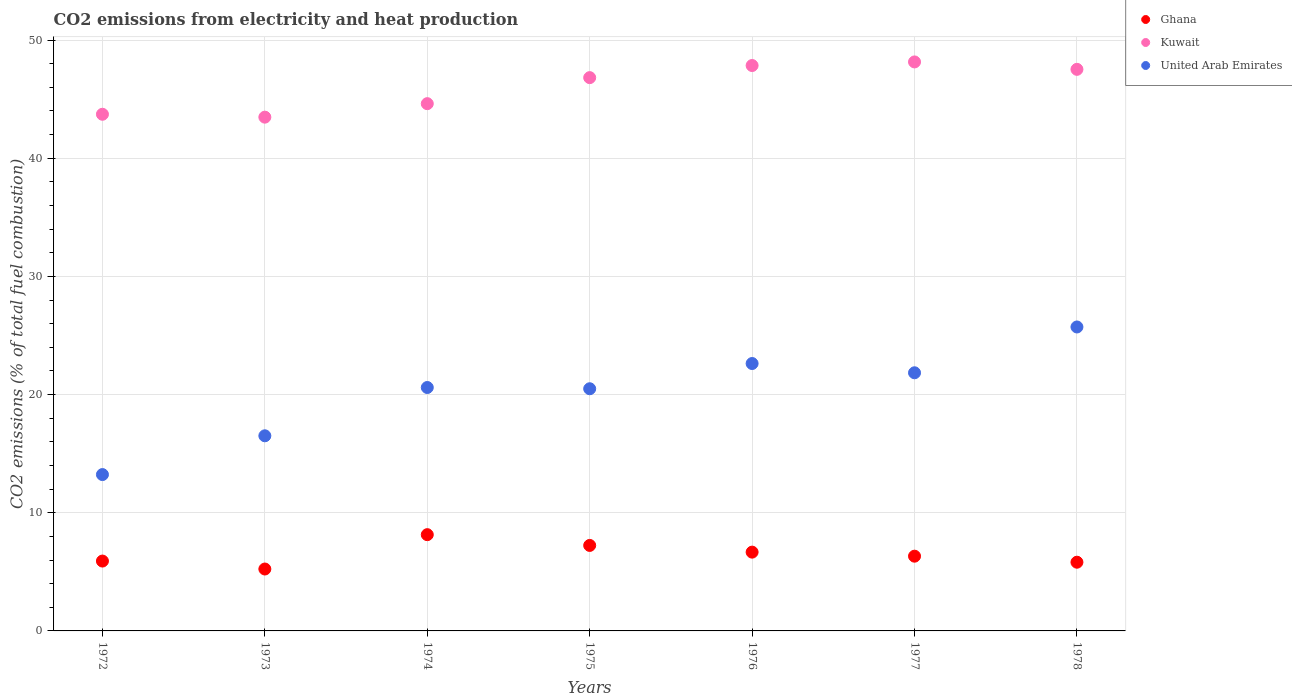How many different coloured dotlines are there?
Make the answer very short. 3. What is the amount of CO2 emitted in Ghana in 1975?
Your answer should be compact. 7.23. Across all years, what is the maximum amount of CO2 emitted in United Arab Emirates?
Provide a short and direct response. 25.72. Across all years, what is the minimum amount of CO2 emitted in Kuwait?
Your response must be concise. 43.47. In which year was the amount of CO2 emitted in Kuwait maximum?
Your answer should be very brief. 1977. In which year was the amount of CO2 emitted in United Arab Emirates minimum?
Ensure brevity in your answer.  1972. What is the total amount of CO2 emitted in United Arab Emirates in the graph?
Your response must be concise. 141.02. What is the difference between the amount of CO2 emitted in Ghana in 1977 and that in 1978?
Your answer should be very brief. 0.51. What is the difference between the amount of CO2 emitted in United Arab Emirates in 1972 and the amount of CO2 emitted in Kuwait in 1978?
Your answer should be compact. -34.29. What is the average amount of CO2 emitted in United Arab Emirates per year?
Provide a short and direct response. 20.15. In the year 1978, what is the difference between the amount of CO2 emitted in United Arab Emirates and amount of CO2 emitted in Kuwait?
Ensure brevity in your answer.  -21.8. What is the ratio of the amount of CO2 emitted in Ghana in 1977 to that in 1978?
Offer a very short reply. 1.09. Is the amount of CO2 emitted in Kuwait in 1974 less than that in 1975?
Your answer should be compact. Yes. What is the difference between the highest and the second highest amount of CO2 emitted in United Arab Emirates?
Give a very brief answer. 3.09. What is the difference between the highest and the lowest amount of CO2 emitted in United Arab Emirates?
Your answer should be very brief. 12.49. Does the amount of CO2 emitted in Ghana monotonically increase over the years?
Give a very brief answer. No. How many years are there in the graph?
Make the answer very short. 7. What is the difference between two consecutive major ticks on the Y-axis?
Provide a succinct answer. 10. Does the graph contain any zero values?
Your answer should be very brief. No. How many legend labels are there?
Offer a very short reply. 3. What is the title of the graph?
Provide a succinct answer. CO2 emissions from electricity and heat production. What is the label or title of the Y-axis?
Offer a very short reply. CO2 emissions (% of total fuel combustion). What is the CO2 emissions (% of total fuel combustion) of Ghana in 1972?
Your answer should be compact. 5.91. What is the CO2 emissions (% of total fuel combustion) of Kuwait in 1972?
Offer a terse response. 43.72. What is the CO2 emissions (% of total fuel combustion) of United Arab Emirates in 1972?
Keep it short and to the point. 13.23. What is the CO2 emissions (% of total fuel combustion) in Ghana in 1973?
Offer a very short reply. 5.24. What is the CO2 emissions (% of total fuel combustion) in Kuwait in 1973?
Provide a succinct answer. 43.47. What is the CO2 emissions (% of total fuel combustion) of United Arab Emirates in 1973?
Your answer should be compact. 16.51. What is the CO2 emissions (% of total fuel combustion) of Ghana in 1974?
Give a very brief answer. 8.14. What is the CO2 emissions (% of total fuel combustion) in Kuwait in 1974?
Your response must be concise. 44.61. What is the CO2 emissions (% of total fuel combustion) in United Arab Emirates in 1974?
Your response must be concise. 20.6. What is the CO2 emissions (% of total fuel combustion) of Ghana in 1975?
Make the answer very short. 7.23. What is the CO2 emissions (% of total fuel combustion) in Kuwait in 1975?
Keep it short and to the point. 46.82. What is the CO2 emissions (% of total fuel combustion) in United Arab Emirates in 1975?
Provide a short and direct response. 20.49. What is the CO2 emissions (% of total fuel combustion) of Ghana in 1976?
Your answer should be very brief. 6.67. What is the CO2 emissions (% of total fuel combustion) of Kuwait in 1976?
Your answer should be compact. 47.84. What is the CO2 emissions (% of total fuel combustion) of United Arab Emirates in 1976?
Give a very brief answer. 22.63. What is the CO2 emissions (% of total fuel combustion) of Ghana in 1977?
Give a very brief answer. 6.32. What is the CO2 emissions (% of total fuel combustion) in Kuwait in 1977?
Ensure brevity in your answer.  48.15. What is the CO2 emissions (% of total fuel combustion) in United Arab Emirates in 1977?
Provide a succinct answer. 21.84. What is the CO2 emissions (% of total fuel combustion) of Ghana in 1978?
Keep it short and to the point. 5.81. What is the CO2 emissions (% of total fuel combustion) in Kuwait in 1978?
Offer a terse response. 47.52. What is the CO2 emissions (% of total fuel combustion) of United Arab Emirates in 1978?
Ensure brevity in your answer.  25.72. Across all years, what is the maximum CO2 emissions (% of total fuel combustion) of Ghana?
Your answer should be very brief. 8.14. Across all years, what is the maximum CO2 emissions (% of total fuel combustion) in Kuwait?
Provide a succinct answer. 48.15. Across all years, what is the maximum CO2 emissions (% of total fuel combustion) in United Arab Emirates?
Provide a short and direct response. 25.72. Across all years, what is the minimum CO2 emissions (% of total fuel combustion) in Ghana?
Offer a terse response. 5.24. Across all years, what is the minimum CO2 emissions (% of total fuel combustion) in Kuwait?
Your answer should be very brief. 43.47. Across all years, what is the minimum CO2 emissions (% of total fuel combustion) in United Arab Emirates?
Provide a succinct answer. 13.23. What is the total CO2 emissions (% of total fuel combustion) of Ghana in the graph?
Ensure brevity in your answer.  45.33. What is the total CO2 emissions (% of total fuel combustion) in Kuwait in the graph?
Give a very brief answer. 322.13. What is the total CO2 emissions (% of total fuel combustion) of United Arab Emirates in the graph?
Your answer should be compact. 141.02. What is the difference between the CO2 emissions (% of total fuel combustion) of Ghana in 1972 and that in 1973?
Offer a very short reply. 0.67. What is the difference between the CO2 emissions (% of total fuel combustion) of Kuwait in 1972 and that in 1973?
Your response must be concise. 0.24. What is the difference between the CO2 emissions (% of total fuel combustion) of United Arab Emirates in 1972 and that in 1973?
Make the answer very short. -3.28. What is the difference between the CO2 emissions (% of total fuel combustion) of Ghana in 1972 and that in 1974?
Keep it short and to the point. -2.23. What is the difference between the CO2 emissions (% of total fuel combustion) of Kuwait in 1972 and that in 1974?
Offer a very short reply. -0.9. What is the difference between the CO2 emissions (% of total fuel combustion) in United Arab Emirates in 1972 and that in 1974?
Make the answer very short. -7.37. What is the difference between the CO2 emissions (% of total fuel combustion) in Ghana in 1972 and that in 1975?
Ensure brevity in your answer.  -1.32. What is the difference between the CO2 emissions (% of total fuel combustion) in Kuwait in 1972 and that in 1975?
Give a very brief answer. -3.1. What is the difference between the CO2 emissions (% of total fuel combustion) in United Arab Emirates in 1972 and that in 1975?
Your answer should be compact. -7.26. What is the difference between the CO2 emissions (% of total fuel combustion) of Ghana in 1972 and that in 1976?
Make the answer very short. -0.76. What is the difference between the CO2 emissions (% of total fuel combustion) in Kuwait in 1972 and that in 1976?
Offer a terse response. -4.12. What is the difference between the CO2 emissions (% of total fuel combustion) in United Arab Emirates in 1972 and that in 1976?
Make the answer very short. -9.4. What is the difference between the CO2 emissions (% of total fuel combustion) of Ghana in 1972 and that in 1977?
Your answer should be very brief. -0.41. What is the difference between the CO2 emissions (% of total fuel combustion) in Kuwait in 1972 and that in 1977?
Keep it short and to the point. -4.43. What is the difference between the CO2 emissions (% of total fuel combustion) in United Arab Emirates in 1972 and that in 1977?
Offer a terse response. -8.61. What is the difference between the CO2 emissions (% of total fuel combustion) in Ghana in 1972 and that in 1978?
Give a very brief answer. 0.1. What is the difference between the CO2 emissions (% of total fuel combustion) in Kuwait in 1972 and that in 1978?
Keep it short and to the point. -3.8. What is the difference between the CO2 emissions (% of total fuel combustion) in United Arab Emirates in 1972 and that in 1978?
Make the answer very short. -12.49. What is the difference between the CO2 emissions (% of total fuel combustion) in Ghana in 1973 and that in 1974?
Give a very brief answer. -2.91. What is the difference between the CO2 emissions (% of total fuel combustion) in Kuwait in 1973 and that in 1974?
Provide a succinct answer. -1.14. What is the difference between the CO2 emissions (% of total fuel combustion) of United Arab Emirates in 1973 and that in 1974?
Ensure brevity in your answer.  -4.09. What is the difference between the CO2 emissions (% of total fuel combustion) of Ghana in 1973 and that in 1975?
Offer a very short reply. -2. What is the difference between the CO2 emissions (% of total fuel combustion) in Kuwait in 1973 and that in 1975?
Offer a terse response. -3.34. What is the difference between the CO2 emissions (% of total fuel combustion) of United Arab Emirates in 1973 and that in 1975?
Make the answer very short. -3.98. What is the difference between the CO2 emissions (% of total fuel combustion) of Ghana in 1973 and that in 1976?
Your response must be concise. -1.43. What is the difference between the CO2 emissions (% of total fuel combustion) in Kuwait in 1973 and that in 1976?
Provide a short and direct response. -4.37. What is the difference between the CO2 emissions (% of total fuel combustion) in United Arab Emirates in 1973 and that in 1976?
Provide a succinct answer. -6.12. What is the difference between the CO2 emissions (% of total fuel combustion) of Ghana in 1973 and that in 1977?
Make the answer very short. -1.09. What is the difference between the CO2 emissions (% of total fuel combustion) in Kuwait in 1973 and that in 1977?
Your answer should be very brief. -4.67. What is the difference between the CO2 emissions (% of total fuel combustion) in United Arab Emirates in 1973 and that in 1977?
Provide a succinct answer. -5.33. What is the difference between the CO2 emissions (% of total fuel combustion) in Ghana in 1973 and that in 1978?
Provide a short and direct response. -0.58. What is the difference between the CO2 emissions (% of total fuel combustion) of Kuwait in 1973 and that in 1978?
Your answer should be very brief. -4.05. What is the difference between the CO2 emissions (% of total fuel combustion) of United Arab Emirates in 1973 and that in 1978?
Provide a succinct answer. -9.21. What is the difference between the CO2 emissions (% of total fuel combustion) in Ghana in 1974 and that in 1975?
Offer a very short reply. 0.91. What is the difference between the CO2 emissions (% of total fuel combustion) in Kuwait in 1974 and that in 1975?
Give a very brief answer. -2.2. What is the difference between the CO2 emissions (% of total fuel combustion) in United Arab Emirates in 1974 and that in 1975?
Your response must be concise. 0.11. What is the difference between the CO2 emissions (% of total fuel combustion) in Ghana in 1974 and that in 1976?
Keep it short and to the point. 1.48. What is the difference between the CO2 emissions (% of total fuel combustion) of Kuwait in 1974 and that in 1976?
Keep it short and to the point. -3.23. What is the difference between the CO2 emissions (% of total fuel combustion) in United Arab Emirates in 1974 and that in 1976?
Give a very brief answer. -2.03. What is the difference between the CO2 emissions (% of total fuel combustion) in Ghana in 1974 and that in 1977?
Provide a succinct answer. 1.82. What is the difference between the CO2 emissions (% of total fuel combustion) of Kuwait in 1974 and that in 1977?
Keep it short and to the point. -3.53. What is the difference between the CO2 emissions (% of total fuel combustion) of United Arab Emirates in 1974 and that in 1977?
Give a very brief answer. -1.25. What is the difference between the CO2 emissions (% of total fuel combustion) in Ghana in 1974 and that in 1978?
Your answer should be very brief. 2.33. What is the difference between the CO2 emissions (% of total fuel combustion) of Kuwait in 1974 and that in 1978?
Your response must be concise. -2.9. What is the difference between the CO2 emissions (% of total fuel combustion) in United Arab Emirates in 1974 and that in 1978?
Provide a short and direct response. -5.12. What is the difference between the CO2 emissions (% of total fuel combustion) of Ghana in 1975 and that in 1976?
Provide a short and direct response. 0.57. What is the difference between the CO2 emissions (% of total fuel combustion) of Kuwait in 1975 and that in 1976?
Provide a short and direct response. -1.02. What is the difference between the CO2 emissions (% of total fuel combustion) of United Arab Emirates in 1975 and that in 1976?
Provide a succinct answer. -2.13. What is the difference between the CO2 emissions (% of total fuel combustion) of Ghana in 1975 and that in 1977?
Give a very brief answer. 0.91. What is the difference between the CO2 emissions (% of total fuel combustion) of Kuwait in 1975 and that in 1977?
Provide a succinct answer. -1.33. What is the difference between the CO2 emissions (% of total fuel combustion) of United Arab Emirates in 1975 and that in 1977?
Your answer should be compact. -1.35. What is the difference between the CO2 emissions (% of total fuel combustion) in Ghana in 1975 and that in 1978?
Give a very brief answer. 1.42. What is the difference between the CO2 emissions (% of total fuel combustion) in Kuwait in 1975 and that in 1978?
Provide a succinct answer. -0.7. What is the difference between the CO2 emissions (% of total fuel combustion) in United Arab Emirates in 1975 and that in 1978?
Your answer should be very brief. -5.23. What is the difference between the CO2 emissions (% of total fuel combustion) of Ghana in 1976 and that in 1977?
Offer a terse response. 0.34. What is the difference between the CO2 emissions (% of total fuel combustion) in Kuwait in 1976 and that in 1977?
Make the answer very short. -0.3. What is the difference between the CO2 emissions (% of total fuel combustion) in United Arab Emirates in 1976 and that in 1977?
Ensure brevity in your answer.  0.78. What is the difference between the CO2 emissions (% of total fuel combustion) of Ghana in 1976 and that in 1978?
Give a very brief answer. 0.85. What is the difference between the CO2 emissions (% of total fuel combustion) in Kuwait in 1976 and that in 1978?
Offer a very short reply. 0.32. What is the difference between the CO2 emissions (% of total fuel combustion) of United Arab Emirates in 1976 and that in 1978?
Your answer should be very brief. -3.09. What is the difference between the CO2 emissions (% of total fuel combustion) in Ghana in 1977 and that in 1978?
Ensure brevity in your answer.  0.51. What is the difference between the CO2 emissions (% of total fuel combustion) in Kuwait in 1977 and that in 1978?
Your answer should be compact. 0.63. What is the difference between the CO2 emissions (% of total fuel combustion) in United Arab Emirates in 1977 and that in 1978?
Keep it short and to the point. -3.88. What is the difference between the CO2 emissions (% of total fuel combustion) in Ghana in 1972 and the CO2 emissions (% of total fuel combustion) in Kuwait in 1973?
Provide a succinct answer. -37.56. What is the difference between the CO2 emissions (% of total fuel combustion) of Ghana in 1972 and the CO2 emissions (% of total fuel combustion) of United Arab Emirates in 1973?
Your response must be concise. -10.6. What is the difference between the CO2 emissions (% of total fuel combustion) in Kuwait in 1972 and the CO2 emissions (% of total fuel combustion) in United Arab Emirates in 1973?
Your answer should be compact. 27.21. What is the difference between the CO2 emissions (% of total fuel combustion) in Ghana in 1972 and the CO2 emissions (% of total fuel combustion) in Kuwait in 1974?
Your answer should be compact. -38.7. What is the difference between the CO2 emissions (% of total fuel combustion) of Ghana in 1972 and the CO2 emissions (% of total fuel combustion) of United Arab Emirates in 1974?
Provide a succinct answer. -14.69. What is the difference between the CO2 emissions (% of total fuel combustion) in Kuwait in 1972 and the CO2 emissions (% of total fuel combustion) in United Arab Emirates in 1974?
Keep it short and to the point. 23.12. What is the difference between the CO2 emissions (% of total fuel combustion) in Ghana in 1972 and the CO2 emissions (% of total fuel combustion) in Kuwait in 1975?
Provide a succinct answer. -40.91. What is the difference between the CO2 emissions (% of total fuel combustion) of Ghana in 1972 and the CO2 emissions (% of total fuel combustion) of United Arab Emirates in 1975?
Your answer should be very brief. -14.58. What is the difference between the CO2 emissions (% of total fuel combustion) of Kuwait in 1972 and the CO2 emissions (% of total fuel combustion) of United Arab Emirates in 1975?
Ensure brevity in your answer.  23.23. What is the difference between the CO2 emissions (% of total fuel combustion) in Ghana in 1972 and the CO2 emissions (% of total fuel combustion) in Kuwait in 1976?
Ensure brevity in your answer.  -41.93. What is the difference between the CO2 emissions (% of total fuel combustion) of Ghana in 1972 and the CO2 emissions (% of total fuel combustion) of United Arab Emirates in 1976?
Keep it short and to the point. -16.72. What is the difference between the CO2 emissions (% of total fuel combustion) in Kuwait in 1972 and the CO2 emissions (% of total fuel combustion) in United Arab Emirates in 1976?
Offer a terse response. 21.09. What is the difference between the CO2 emissions (% of total fuel combustion) of Ghana in 1972 and the CO2 emissions (% of total fuel combustion) of Kuwait in 1977?
Your answer should be very brief. -42.23. What is the difference between the CO2 emissions (% of total fuel combustion) in Ghana in 1972 and the CO2 emissions (% of total fuel combustion) in United Arab Emirates in 1977?
Your answer should be compact. -15.93. What is the difference between the CO2 emissions (% of total fuel combustion) of Kuwait in 1972 and the CO2 emissions (% of total fuel combustion) of United Arab Emirates in 1977?
Offer a very short reply. 21.88. What is the difference between the CO2 emissions (% of total fuel combustion) of Ghana in 1972 and the CO2 emissions (% of total fuel combustion) of Kuwait in 1978?
Make the answer very short. -41.61. What is the difference between the CO2 emissions (% of total fuel combustion) in Ghana in 1972 and the CO2 emissions (% of total fuel combustion) in United Arab Emirates in 1978?
Offer a very short reply. -19.81. What is the difference between the CO2 emissions (% of total fuel combustion) in Kuwait in 1972 and the CO2 emissions (% of total fuel combustion) in United Arab Emirates in 1978?
Make the answer very short. 18. What is the difference between the CO2 emissions (% of total fuel combustion) of Ghana in 1973 and the CO2 emissions (% of total fuel combustion) of Kuwait in 1974?
Provide a short and direct response. -39.38. What is the difference between the CO2 emissions (% of total fuel combustion) of Ghana in 1973 and the CO2 emissions (% of total fuel combustion) of United Arab Emirates in 1974?
Offer a very short reply. -15.36. What is the difference between the CO2 emissions (% of total fuel combustion) in Kuwait in 1973 and the CO2 emissions (% of total fuel combustion) in United Arab Emirates in 1974?
Make the answer very short. 22.88. What is the difference between the CO2 emissions (% of total fuel combustion) of Ghana in 1973 and the CO2 emissions (% of total fuel combustion) of Kuwait in 1975?
Provide a short and direct response. -41.58. What is the difference between the CO2 emissions (% of total fuel combustion) in Ghana in 1973 and the CO2 emissions (% of total fuel combustion) in United Arab Emirates in 1975?
Keep it short and to the point. -15.25. What is the difference between the CO2 emissions (% of total fuel combustion) in Kuwait in 1973 and the CO2 emissions (% of total fuel combustion) in United Arab Emirates in 1975?
Offer a very short reply. 22.98. What is the difference between the CO2 emissions (% of total fuel combustion) in Ghana in 1973 and the CO2 emissions (% of total fuel combustion) in Kuwait in 1976?
Give a very brief answer. -42.6. What is the difference between the CO2 emissions (% of total fuel combustion) of Ghana in 1973 and the CO2 emissions (% of total fuel combustion) of United Arab Emirates in 1976?
Provide a short and direct response. -17.39. What is the difference between the CO2 emissions (% of total fuel combustion) of Kuwait in 1973 and the CO2 emissions (% of total fuel combustion) of United Arab Emirates in 1976?
Offer a very short reply. 20.85. What is the difference between the CO2 emissions (% of total fuel combustion) of Ghana in 1973 and the CO2 emissions (% of total fuel combustion) of Kuwait in 1977?
Your response must be concise. -42.91. What is the difference between the CO2 emissions (% of total fuel combustion) in Ghana in 1973 and the CO2 emissions (% of total fuel combustion) in United Arab Emirates in 1977?
Your answer should be compact. -16.6. What is the difference between the CO2 emissions (% of total fuel combustion) in Kuwait in 1973 and the CO2 emissions (% of total fuel combustion) in United Arab Emirates in 1977?
Make the answer very short. 21.63. What is the difference between the CO2 emissions (% of total fuel combustion) of Ghana in 1973 and the CO2 emissions (% of total fuel combustion) of Kuwait in 1978?
Offer a terse response. -42.28. What is the difference between the CO2 emissions (% of total fuel combustion) of Ghana in 1973 and the CO2 emissions (% of total fuel combustion) of United Arab Emirates in 1978?
Offer a very short reply. -20.48. What is the difference between the CO2 emissions (% of total fuel combustion) in Kuwait in 1973 and the CO2 emissions (% of total fuel combustion) in United Arab Emirates in 1978?
Provide a short and direct response. 17.75. What is the difference between the CO2 emissions (% of total fuel combustion) of Ghana in 1974 and the CO2 emissions (% of total fuel combustion) of Kuwait in 1975?
Keep it short and to the point. -38.67. What is the difference between the CO2 emissions (% of total fuel combustion) of Ghana in 1974 and the CO2 emissions (% of total fuel combustion) of United Arab Emirates in 1975?
Offer a terse response. -12.35. What is the difference between the CO2 emissions (% of total fuel combustion) of Kuwait in 1974 and the CO2 emissions (% of total fuel combustion) of United Arab Emirates in 1975?
Make the answer very short. 24.12. What is the difference between the CO2 emissions (% of total fuel combustion) in Ghana in 1974 and the CO2 emissions (% of total fuel combustion) in Kuwait in 1976?
Ensure brevity in your answer.  -39.7. What is the difference between the CO2 emissions (% of total fuel combustion) in Ghana in 1974 and the CO2 emissions (% of total fuel combustion) in United Arab Emirates in 1976?
Offer a terse response. -14.48. What is the difference between the CO2 emissions (% of total fuel combustion) in Kuwait in 1974 and the CO2 emissions (% of total fuel combustion) in United Arab Emirates in 1976?
Make the answer very short. 21.99. What is the difference between the CO2 emissions (% of total fuel combustion) in Ghana in 1974 and the CO2 emissions (% of total fuel combustion) in Kuwait in 1977?
Offer a terse response. -40. What is the difference between the CO2 emissions (% of total fuel combustion) in Ghana in 1974 and the CO2 emissions (% of total fuel combustion) in United Arab Emirates in 1977?
Ensure brevity in your answer.  -13.7. What is the difference between the CO2 emissions (% of total fuel combustion) in Kuwait in 1974 and the CO2 emissions (% of total fuel combustion) in United Arab Emirates in 1977?
Provide a short and direct response. 22.77. What is the difference between the CO2 emissions (% of total fuel combustion) of Ghana in 1974 and the CO2 emissions (% of total fuel combustion) of Kuwait in 1978?
Keep it short and to the point. -39.37. What is the difference between the CO2 emissions (% of total fuel combustion) of Ghana in 1974 and the CO2 emissions (% of total fuel combustion) of United Arab Emirates in 1978?
Make the answer very short. -17.57. What is the difference between the CO2 emissions (% of total fuel combustion) of Kuwait in 1974 and the CO2 emissions (% of total fuel combustion) of United Arab Emirates in 1978?
Provide a succinct answer. 18.9. What is the difference between the CO2 emissions (% of total fuel combustion) in Ghana in 1975 and the CO2 emissions (% of total fuel combustion) in Kuwait in 1976?
Your response must be concise. -40.61. What is the difference between the CO2 emissions (% of total fuel combustion) in Ghana in 1975 and the CO2 emissions (% of total fuel combustion) in United Arab Emirates in 1976?
Your response must be concise. -15.39. What is the difference between the CO2 emissions (% of total fuel combustion) in Kuwait in 1975 and the CO2 emissions (% of total fuel combustion) in United Arab Emirates in 1976?
Your answer should be very brief. 24.19. What is the difference between the CO2 emissions (% of total fuel combustion) of Ghana in 1975 and the CO2 emissions (% of total fuel combustion) of Kuwait in 1977?
Your response must be concise. -40.91. What is the difference between the CO2 emissions (% of total fuel combustion) of Ghana in 1975 and the CO2 emissions (% of total fuel combustion) of United Arab Emirates in 1977?
Provide a short and direct response. -14.61. What is the difference between the CO2 emissions (% of total fuel combustion) in Kuwait in 1975 and the CO2 emissions (% of total fuel combustion) in United Arab Emirates in 1977?
Offer a terse response. 24.97. What is the difference between the CO2 emissions (% of total fuel combustion) of Ghana in 1975 and the CO2 emissions (% of total fuel combustion) of Kuwait in 1978?
Offer a very short reply. -40.28. What is the difference between the CO2 emissions (% of total fuel combustion) of Ghana in 1975 and the CO2 emissions (% of total fuel combustion) of United Arab Emirates in 1978?
Make the answer very short. -18.48. What is the difference between the CO2 emissions (% of total fuel combustion) of Kuwait in 1975 and the CO2 emissions (% of total fuel combustion) of United Arab Emirates in 1978?
Give a very brief answer. 21.1. What is the difference between the CO2 emissions (% of total fuel combustion) of Ghana in 1976 and the CO2 emissions (% of total fuel combustion) of Kuwait in 1977?
Make the answer very short. -41.48. What is the difference between the CO2 emissions (% of total fuel combustion) in Ghana in 1976 and the CO2 emissions (% of total fuel combustion) in United Arab Emirates in 1977?
Provide a short and direct response. -15.18. What is the difference between the CO2 emissions (% of total fuel combustion) of Kuwait in 1976 and the CO2 emissions (% of total fuel combustion) of United Arab Emirates in 1977?
Offer a very short reply. 26. What is the difference between the CO2 emissions (% of total fuel combustion) in Ghana in 1976 and the CO2 emissions (% of total fuel combustion) in Kuwait in 1978?
Your response must be concise. -40.85. What is the difference between the CO2 emissions (% of total fuel combustion) in Ghana in 1976 and the CO2 emissions (% of total fuel combustion) in United Arab Emirates in 1978?
Your response must be concise. -19.05. What is the difference between the CO2 emissions (% of total fuel combustion) of Kuwait in 1976 and the CO2 emissions (% of total fuel combustion) of United Arab Emirates in 1978?
Your response must be concise. 22.12. What is the difference between the CO2 emissions (% of total fuel combustion) in Ghana in 1977 and the CO2 emissions (% of total fuel combustion) in Kuwait in 1978?
Provide a succinct answer. -41.19. What is the difference between the CO2 emissions (% of total fuel combustion) of Ghana in 1977 and the CO2 emissions (% of total fuel combustion) of United Arab Emirates in 1978?
Offer a terse response. -19.39. What is the difference between the CO2 emissions (% of total fuel combustion) in Kuwait in 1977 and the CO2 emissions (% of total fuel combustion) in United Arab Emirates in 1978?
Your answer should be compact. 22.43. What is the average CO2 emissions (% of total fuel combustion) of Ghana per year?
Your response must be concise. 6.48. What is the average CO2 emissions (% of total fuel combustion) in Kuwait per year?
Your response must be concise. 46.02. What is the average CO2 emissions (% of total fuel combustion) of United Arab Emirates per year?
Provide a succinct answer. 20.15. In the year 1972, what is the difference between the CO2 emissions (% of total fuel combustion) of Ghana and CO2 emissions (% of total fuel combustion) of Kuwait?
Offer a terse response. -37.81. In the year 1972, what is the difference between the CO2 emissions (% of total fuel combustion) in Ghana and CO2 emissions (% of total fuel combustion) in United Arab Emirates?
Provide a succinct answer. -7.32. In the year 1972, what is the difference between the CO2 emissions (% of total fuel combustion) of Kuwait and CO2 emissions (% of total fuel combustion) of United Arab Emirates?
Your answer should be very brief. 30.49. In the year 1973, what is the difference between the CO2 emissions (% of total fuel combustion) in Ghana and CO2 emissions (% of total fuel combustion) in Kuwait?
Keep it short and to the point. -38.23. In the year 1973, what is the difference between the CO2 emissions (% of total fuel combustion) in Ghana and CO2 emissions (% of total fuel combustion) in United Arab Emirates?
Your answer should be very brief. -11.27. In the year 1973, what is the difference between the CO2 emissions (% of total fuel combustion) in Kuwait and CO2 emissions (% of total fuel combustion) in United Arab Emirates?
Your response must be concise. 26.96. In the year 1974, what is the difference between the CO2 emissions (% of total fuel combustion) of Ghana and CO2 emissions (% of total fuel combustion) of Kuwait?
Keep it short and to the point. -36.47. In the year 1974, what is the difference between the CO2 emissions (% of total fuel combustion) of Ghana and CO2 emissions (% of total fuel combustion) of United Arab Emirates?
Ensure brevity in your answer.  -12.45. In the year 1974, what is the difference between the CO2 emissions (% of total fuel combustion) in Kuwait and CO2 emissions (% of total fuel combustion) in United Arab Emirates?
Your response must be concise. 24.02. In the year 1975, what is the difference between the CO2 emissions (% of total fuel combustion) of Ghana and CO2 emissions (% of total fuel combustion) of Kuwait?
Make the answer very short. -39.58. In the year 1975, what is the difference between the CO2 emissions (% of total fuel combustion) in Ghana and CO2 emissions (% of total fuel combustion) in United Arab Emirates?
Your response must be concise. -13.26. In the year 1975, what is the difference between the CO2 emissions (% of total fuel combustion) of Kuwait and CO2 emissions (% of total fuel combustion) of United Arab Emirates?
Keep it short and to the point. 26.33. In the year 1976, what is the difference between the CO2 emissions (% of total fuel combustion) in Ghana and CO2 emissions (% of total fuel combustion) in Kuwait?
Keep it short and to the point. -41.18. In the year 1976, what is the difference between the CO2 emissions (% of total fuel combustion) in Ghana and CO2 emissions (% of total fuel combustion) in United Arab Emirates?
Give a very brief answer. -15.96. In the year 1976, what is the difference between the CO2 emissions (% of total fuel combustion) in Kuwait and CO2 emissions (% of total fuel combustion) in United Arab Emirates?
Make the answer very short. 25.22. In the year 1977, what is the difference between the CO2 emissions (% of total fuel combustion) of Ghana and CO2 emissions (% of total fuel combustion) of Kuwait?
Give a very brief answer. -41.82. In the year 1977, what is the difference between the CO2 emissions (% of total fuel combustion) of Ghana and CO2 emissions (% of total fuel combustion) of United Arab Emirates?
Ensure brevity in your answer.  -15.52. In the year 1977, what is the difference between the CO2 emissions (% of total fuel combustion) of Kuwait and CO2 emissions (% of total fuel combustion) of United Arab Emirates?
Your answer should be compact. 26.3. In the year 1978, what is the difference between the CO2 emissions (% of total fuel combustion) of Ghana and CO2 emissions (% of total fuel combustion) of Kuwait?
Provide a short and direct response. -41.7. In the year 1978, what is the difference between the CO2 emissions (% of total fuel combustion) of Ghana and CO2 emissions (% of total fuel combustion) of United Arab Emirates?
Offer a very short reply. -19.91. In the year 1978, what is the difference between the CO2 emissions (% of total fuel combustion) of Kuwait and CO2 emissions (% of total fuel combustion) of United Arab Emirates?
Provide a succinct answer. 21.8. What is the ratio of the CO2 emissions (% of total fuel combustion) of Ghana in 1972 to that in 1973?
Provide a succinct answer. 1.13. What is the ratio of the CO2 emissions (% of total fuel combustion) of Kuwait in 1972 to that in 1973?
Your response must be concise. 1.01. What is the ratio of the CO2 emissions (% of total fuel combustion) in United Arab Emirates in 1972 to that in 1973?
Ensure brevity in your answer.  0.8. What is the ratio of the CO2 emissions (% of total fuel combustion) of Ghana in 1972 to that in 1974?
Provide a short and direct response. 0.73. What is the ratio of the CO2 emissions (% of total fuel combustion) in Kuwait in 1972 to that in 1974?
Offer a very short reply. 0.98. What is the ratio of the CO2 emissions (% of total fuel combustion) in United Arab Emirates in 1972 to that in 1974?
Your answer should be very brief. 0.64. What is the ratio of the CO2 emissions (% of total fuel combustion) of Ghana in 1972 to that in 1975?
Your answer should be very brief. 0.82. What is the ratio of the CO2 emissions (% of total fuel combustion) in Kuwait in 1972 to that in 1975?
Your response must be concise. 0.93. What is the ratio of the CO2 emissions (% of total fuel combustion) in United Arab Emirates in 1972 to that in 1975?
Your answer should be compact. 0.65. What is the ratio of the CO2 emissions (% of total fuel combustion) in Ghana in 1972 to that in 1976?
Your answer should be very brief. 0.89. What is the ratio of the CO2 emissions (% of total fuel combustion) of Kuwait in 1972 to that in 1976?
Offer a very short reply. 0.91. What is the ratio of the CO2 emissions (% of total fuel combustion) in United Arab Emirates in 1972 to that in 1976?
Ensure brevity in your answer.  0.58. What is the ratio of the CO2 emissions (% of total fuel combustion) in Ghana in 1972 to that in 1977?
Your answer should be compact. 0.93. What is the ratio of the CO2 emissions (% of total fuel combustion) in Kuwait in 1972 to that in 1977?
Offer a terse response. 0.91. What is the ratio of the CO2 emissions (% of total fuel combustion) of United Arab Emirates in 1972 to that in 1977?
Offer a terse response. 0.61. What is the ratio of the CO2 emissions (% of total fuel combustion) in Ghana in 1972 to that in 1978?
Provide a short and direct response. 1.02. What is the ratio of the CO2 emissions (% of total fuel combustion) in United Arab Emirates in 1972 to that in 1978?
Keep it short and to the point. 0.51. What is the ratio of the CO2 emissions (% of total fuel combustion) of Ghana in 1973 to that in 1974?
Provide a succinct answer. 0.64. What is the ratio of the CO2 emissions (% of total fuel combustion) in Kuwait in 1973 to that in 1974?
Provide a short and direct response. 0.97. What is the ratio of the CO2 emissions (% of total fuel combustion) of United Arab Emirates in 1973 to that in 1974?
Offer a very short reply. 0.8. What is the ratio of the CO2 emissions (% of total fuel combustion) in Ghana in 1973 to that in 1975?
Your answer should be compact. 0.72. What is the ratio of the CO2 emissions (% of total fuel combustion) in Kuwait in 1973 to that in 1975?
Offer a very short reply. 0.93. What is the ratio of the CO2 emissions (% of total fuel combustion) in United Arab Emirates in 1973 to that in 1975?
Give a very brief answer. 0.81. What is the ratio of the CO2 emissions (% of total fuel combustion) in Ghana in 1973 to that in 1976?
Your answer should be very brief. 0.79. What is the ratio of the CO2 emissions (% of total fuel combustion) in Kuwait in 1973 to that in 1976?
Provide a succinct answer. 0.91. What is the ratio of the CO2 emissions (% of total fuel combustion) in United Arab Emirates in 1973 to that in 1976?
Give a very brief answer. 0.73. What is the ratio of the CO2 emissions (% of total fuel combustion) of Ghana in 1973 to that in 1977?
Keep it short and to the point. 0.83. What is the ratio of the CO2 emissions (% of total fuel combustion) in Kuwait in 1973 to that in 1977?
Keep it short and to the point. 0.9. What is the ratio of the CO2 emissions (% of total fuel combustion) in United Arab Emirates in 1973 to that in 1977?
Provide a succinct answer. 0.76. What is the ratio of the CO2 emissions (% of total fuel combustion) of Ghana in 1973 to that in 1978?
Your answer should be very brief. 0.9. What is the ratio of the CO2 emissions (% of total fuel combustion) of Kuwait in 1973 to that in 1978?
Provide a succinct answer. 0.91. What is the ratio of the CO2 emissions (% of total fuel combustion) in United Arab Emirates in 1973 to that in 1978?
Offer a very short reply. 0.64. What is the ratio of the CO2 emissions (% of total fuel combustion) of Ghana in 1974 to that in 1975?
Provide a short and direct response. 1.13. What is the ratio of the CO2 emissions (% of total fuel combustion) of Kuwait in 1974 to that in 1975?
Keep it short and to the point. 0.95. What is the ratio of the CO2 emissions (% of total fuel combustion) of Ghana in 1974 to that in 1976?
Keep it short and to the point. 1.22. What is the ratio of the CO2 emissions (% of total fuel combustion) of Kuwait in 1974 to that in 1976?
Provide a succinct answer. 0.93. What is the ratio of the CO2 emissions (% of total fuel combustion) of United Arab Emirates in 1974 to that in 1976?
Provide a short and direct response. 0.91. What is the ratio of the CO2 emissions (% of total fuel combustion) of Ghana in 1974 to that in 1977?
Your answer should be compact. 1.29. What is the ratio of the CO2 emissions (% of total fuel combustion) in Kuwait in 1974 to that in 1977?
Keep it short and to the point. 0.93. What is the ratio of the CO2 emissions (% of total fuel combustion) of United Arab Emirates in 1974 to that in 1977?
Offer a very short reply. 0.94. What is the ratio of the CO2 emissions (% of total fuel combustion) in Ghana in 1974 to that in 1978?
Ensure brevity in your answer.  1.4. What is the ratio of the CO2 emissions (% of total fuel combustion) of Kuwait in 1974 to that in 1978?
Offer a very short reply. 0.94. What is the ratio of the CO2 emissions (% of total fuel combustion) in United Arab Emirates in 1974 to that in 1978?
Offer a terse response. 0.8. What is the ratio of the CO2 emissions (% of total fuel combustion) of Ghana in 1975 to that in 1976?
Your answer should be compact. 1.09. What is the ratio of the CO2 emissions (% of total fuel combustion) of Kuwait in 1975 to that in 1976?
Provide a succinct answer. 0.98. What is the ratio of the CO2 emissions (% of total fuel combustion) of United Arab Emirates in 1975 to that in 1976?
Your response must be concise. 0.91. What is the ratio of the CO2 emissions (% of total fuel combustion) in Ghana in 1975 to that in 1977?
Offer a terse response. 1.14. What is the ratio of the CO2 emissions (% of total fuel combustion) in Kuwait in 1975 to that in 1977?
Give a very brief answer. 0.97. What is the ratio of the CO2 emissions (% of total fuel combustion) in United Arab Emirates in 1975 to that in 1977?
Your answer should be compact. 0.94. What is the ratio of the CO2 emissions (% of total fuel combustion) of Ghana in 1975 to that in 1978?
Keep it short and to the point. 1.24. What is the ratio of the CO2 emissions (% of total fuel combustion) of Kuwait in 1975 to that in 1978?
Give a very brief answer. 0.99. What is the ratio of the CO2 emissions (% of total fuel combustion) in United Arab Emirates in 1975 to that in 1978?
Provide a succinct answer. 0.8. What is the ratio of the CO2 emissions (% of total fuel combustion) of Ghana in 1976 to that in 1977?
Ensure brevity in your answer.  1.05. What is the ratio of the CO2 emissions (% of total fuel combustion) in Kuwait in 1976 to that in 1977?
Ensure brevity in your answer.  0.99. What is the ratio of the CO2 emissions (% of total fuel combustion) of United Arab Emirates in 1976 to that in 1977?
Keep it short and to the point. 1.04. What is the ratio of the CO2 emissions (% of total fuel combustion) of Ghana in 1976 to that in 1978?
Keep it short and to the point. 1.15. What is the ratio of the CO2 emissions (% of total fuel combustion) of Kuwait in 1976 to that in 1978?
Your response must be concise. 1.01. What is the ratio of the CO2 emissions (% of total fuel combustion) of United Arab Emirates in 1976 to that in 1978?
Your response must be concise. 0.88. What is the ratio of the CO2 emissions (% of total fuel combustion) in Ghana in 1977 to that in 1978?
Give a very brief answer. 1.09. What is the ratio of the CO2 emissions (% of total fuel combustion) of Kuwait in 1977 to that in 1978?
Your response must be concise. 1.01. What is the ratio of the CO2 emissions (% of total fuel combustion) in United Arab Emirates in 1977 to that in 1978?
Provide a succinct answer. 0.85. What is the difference between the highest and the second highest CO2 emissions (% of total fuel combustion) of Ghana?
Your response must be concise. 0.91. What is the difference between the highest and the second highest CO2 emissions (% of total fuel combustion) in Kuwait?
Provide a succinct answer. 0.3. What is the difference between the highest and the second highest CO2 emissions (% of total fuel combustion) in United Arab Emirates?
Provide a succinct answer. 3.09. What is the difference between the highest and the lowest CO2 emissions (% of total fuel combustion) in Ghana?
Keep it short and to the point. 2.91. What is the difference between the highest and the lowest CO2 emissions (% of total fuel combustion) in Kuwait?
Offer a terse response. 4.67. What is the difference between the highest and the lowest CO2 emissions (% of total fuel combustion) in United Arab Emirates?
Your answer should be very brief. 12.49. 